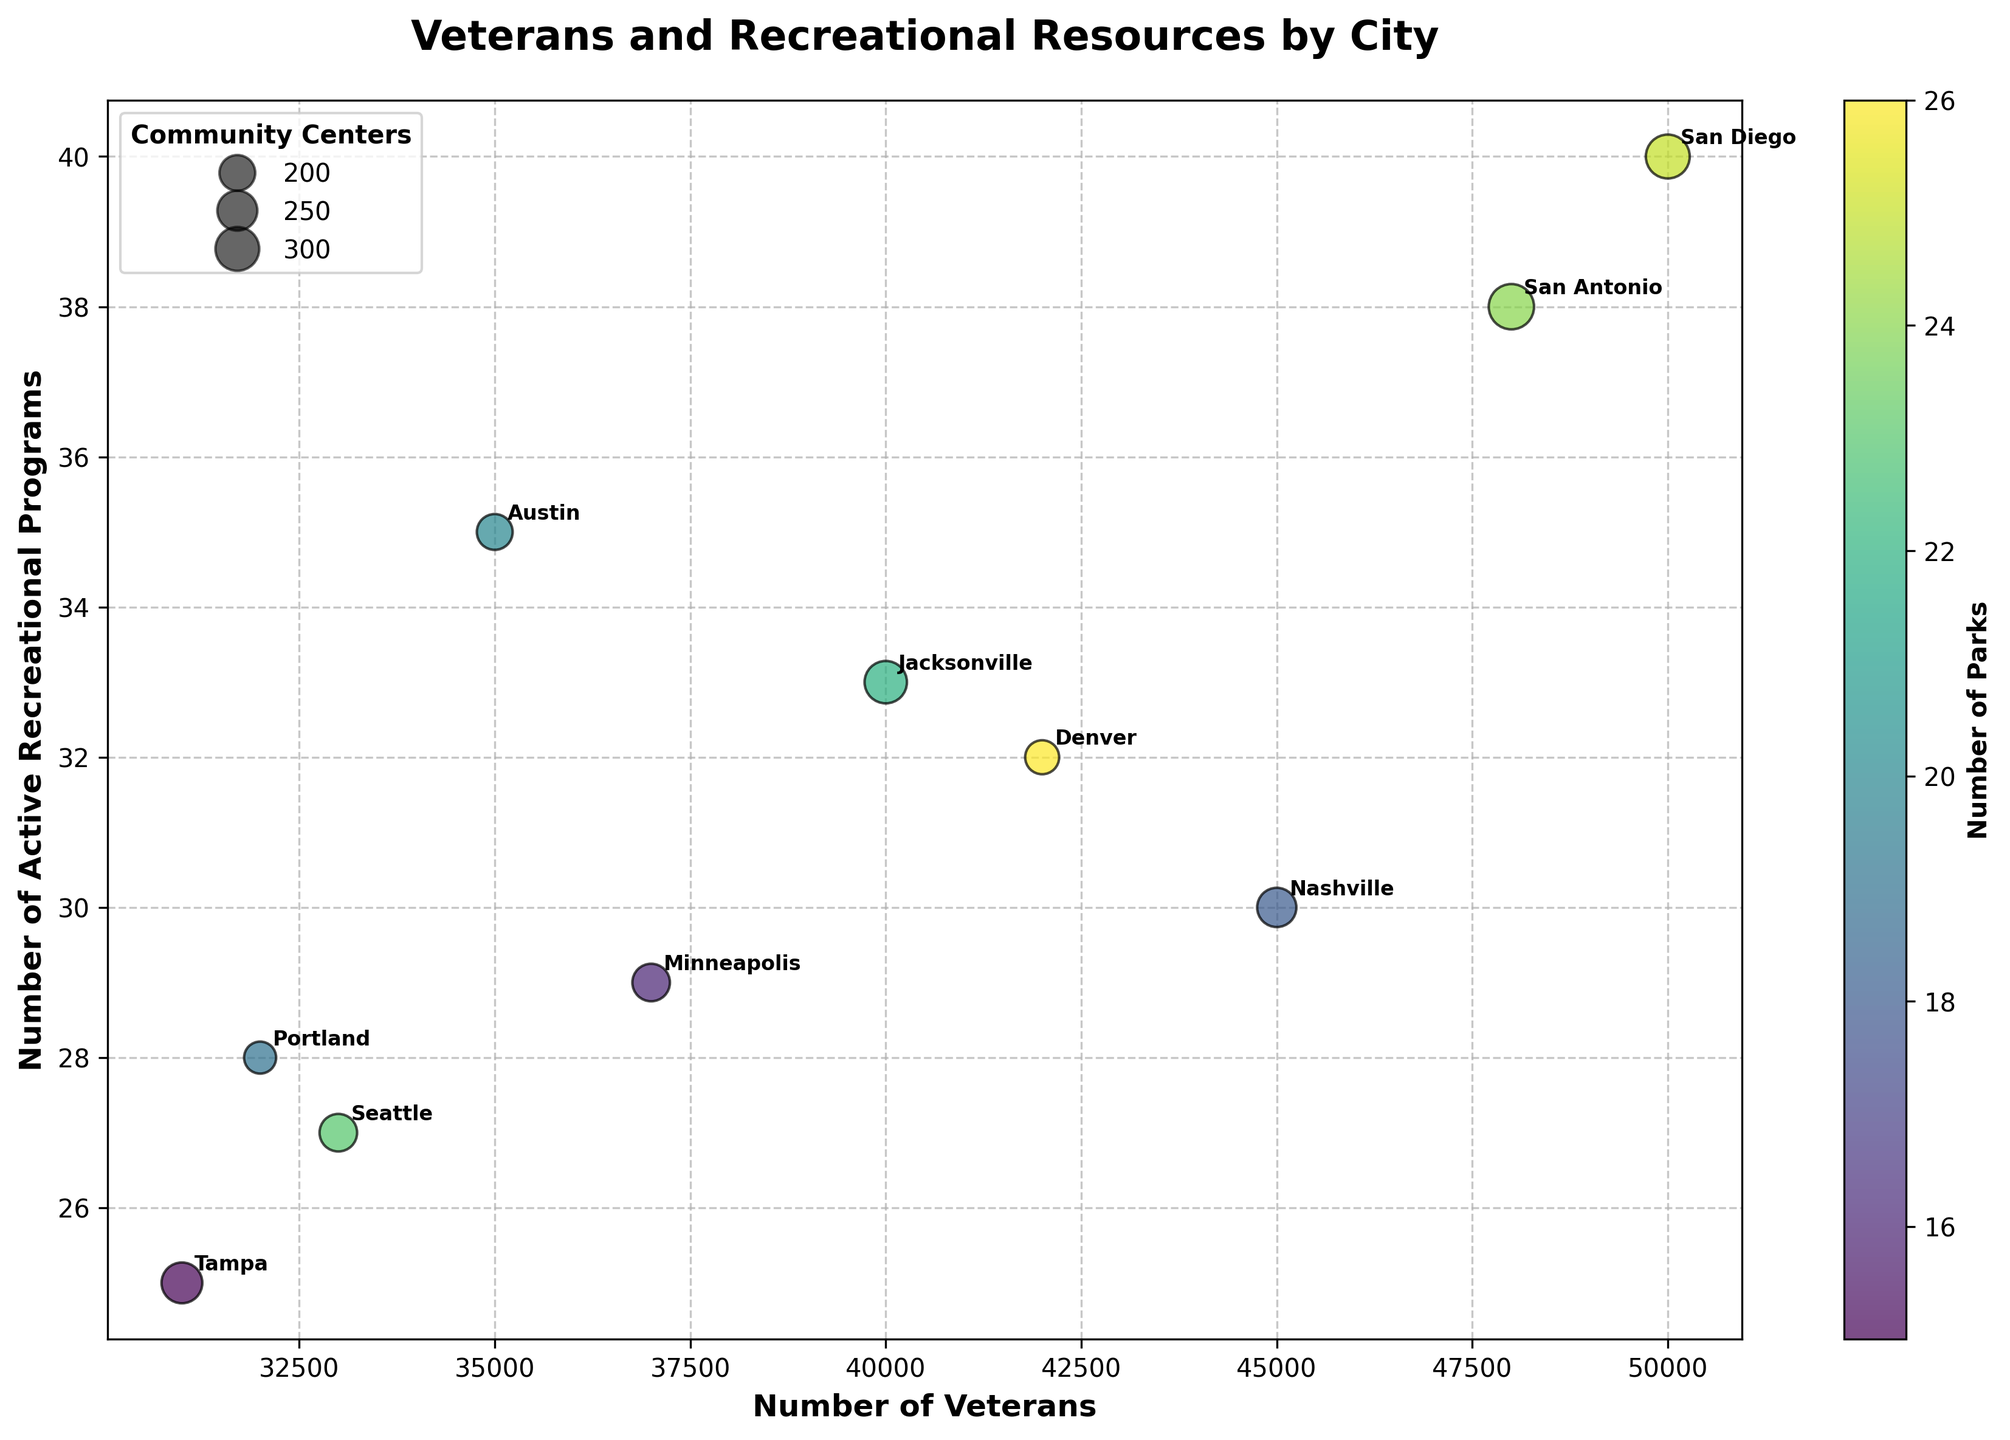How many cities have over 40,000 veterans? According to the plot, the x-axis represents the number of veterans. By checking each point, we find that San Diego, Nashville, Jacksonville, Denver, and San Antonio all have more than 40,000 veterans.
Answer: 5 Which city has the most active recreational programs? The y-axis represents the number of active recreational programs. The highest point on the y-axis corresponds to San Diego, highlighting it as having the most programs.
Answer: San Diego Which city has the smallest bubble in the scatter plot? The size of each bubble represents the number of community centers in each city. The smallest bubble corresponds to Portland, indicating it has the fewest community centers.
Answer: Portland Which city has the highest number of parks? The color of the bubbles represents the number of parks, with darker bubbles indicating more parks. Denver has the darkest colored bubble, signifying it has the highest number of parks.
Answer: Denver What is the combined number of veterans in Minneapolis and Tampa? Minneapolis has 37,000 veterans, and Tampa has 31,000 veterans. Adding these numbers together, we get 37,000 + 31,000 = 68,000.
Answer: 68,000 Which city has a higher number of active recreational programs: Austin or Nashville? The y-axis shows the number of active recreational programs. Austin has 35 programs, while Nashville has 30. Therefore, Austin has more active programs.
Answer: Austin Of the cities with fewer than 35,000 veterans, which has the most community centers? Among the cities with fewer than 35,000 veterans—Portland, Tampa, and Seattle—Tampa has the most community centers with 13.
Answer: Tampa Do any cities have more parks than community centers? By comparing the numbers, it is clear that all cities have more parks than community centers as indicated by their associated bubble color and size.
Answer: Yes Which cities have more than 30 active recreational programs but less than 45,000 veterans? Austin (35 programs, 35,000 veterans), Minneapolis (29 programs, 37,000 veterans), Denver (32 programs, 42,000 veterans), Seattle (27 programs, 33,000 veterans) meet this criterion.
Answer: Austin, Minneapolis, Seattle Is there a positive correlation between the number of veterans and active recreational programs? By observing the general trend of the scatter plot, we see that as the number of veterans increases, the number of active recreational programs also tends to increase, indicating a positive correlation.
Answer: Yes 